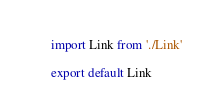Convert code to text. <code><loc_0><loc_0><loc_500><loc_500><_JavaScript_>import Link from './Link'

export default Link</code> 